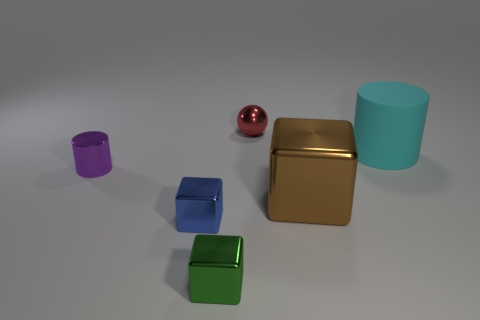There is another large shiny thing that is the same shape as the blue metal object; what color is it? brown 